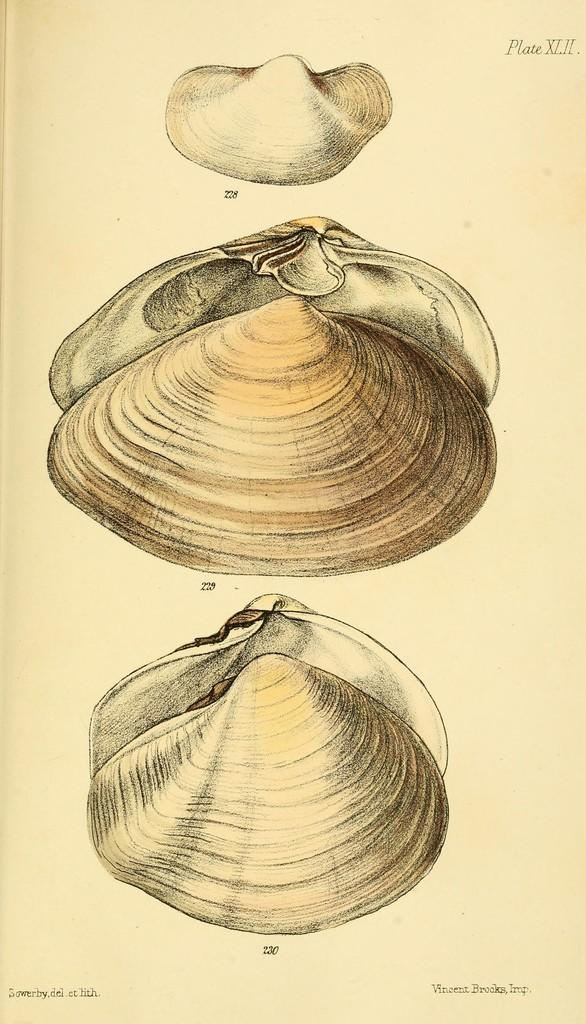What is the main subject of the image? The main subject of the image is pictures on a shell. What is the material on which the pictures are printed? The pictures are on a paper. Are there any words written on the paper? Yes, there are texts written on the paper at the top and bottom. How do the dinosaurs feel about the loss of their habitat in the image? There are no dinosaurs present in the image, so it is not possible to determine their feelings about the loss of their habitat. 